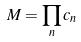<formula> <loc_0><loc_0><loc_500><loc_500>M = \prod _ { n } c _ { n }</formula> 